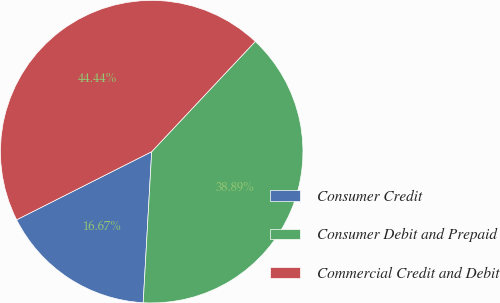Convert chart to OTSL. <chart><loc_0><loc_0><loc_500><loc_500><pie_chart><fcel>Consumer Credit<fcel>Consumer Debit and Prepaid<fcel>Commercial Credit and Debit<nl><fcel>16.67%<fcel>38.89%<fcel>44.44%<nl></chart> 